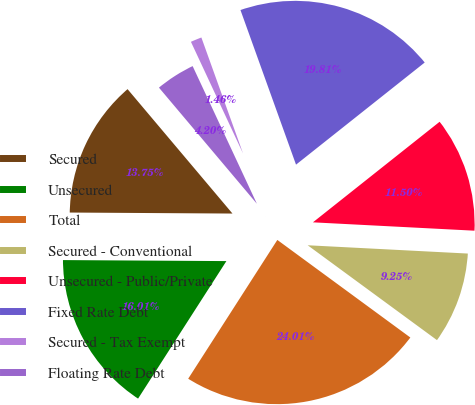Convert chart to OTSL. <chart><loc_0><loc_0><loc_500><loc_500><pie_chart><fcel>Secured<fcel>Unsecured<fcel>Total<fcel>Secured - Conventional<fcel>Unsecured - Public/Private<fcel>Fixed Rate Debt<fcel>Secured - Tax Exempt<fcel>Floating Rate Debt<nl><fcel>13.75%<fcel>16.01%<fcel>24.01%<fcel>9.25%<fcel>11.5%<fcel>19.81%<fcel>1.46%<fcel>4.2%<nl></chart> 